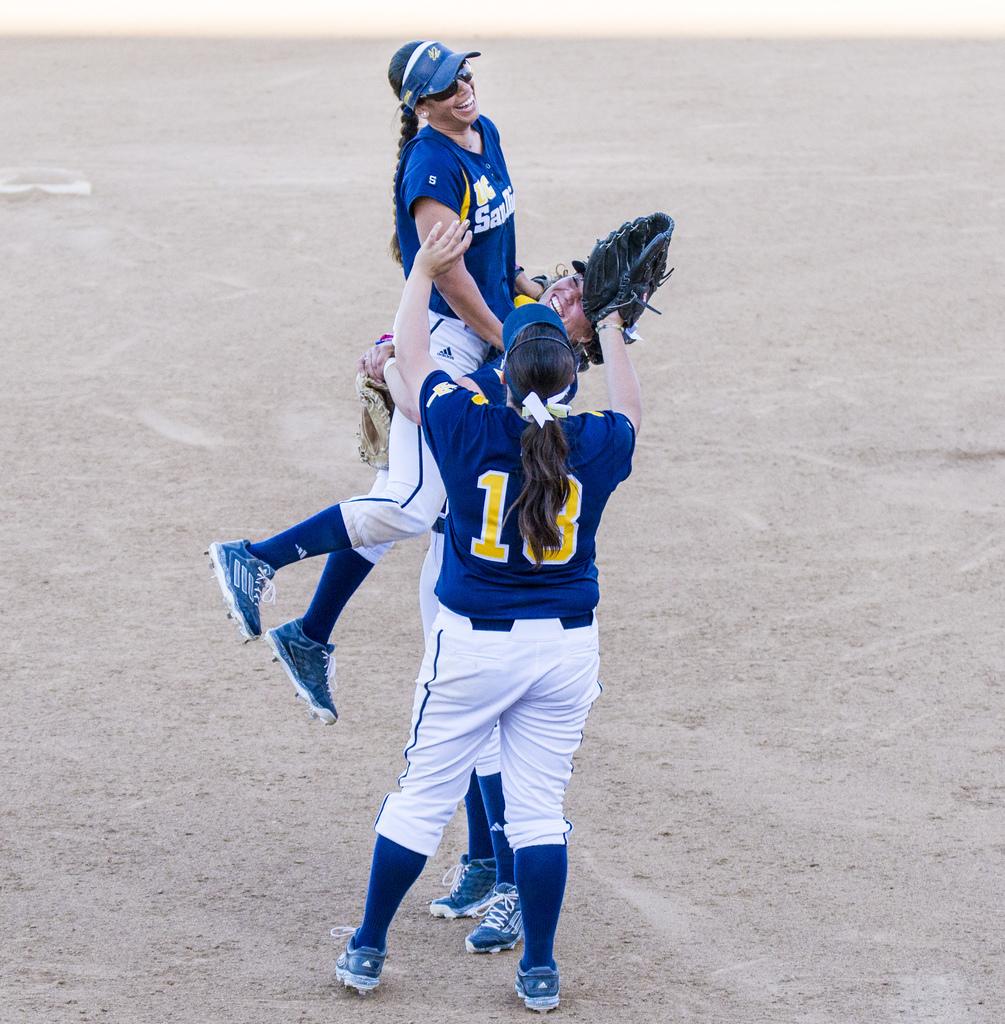What number is on the back of the players jersey?
Ensure brevity in your answer.  18. 